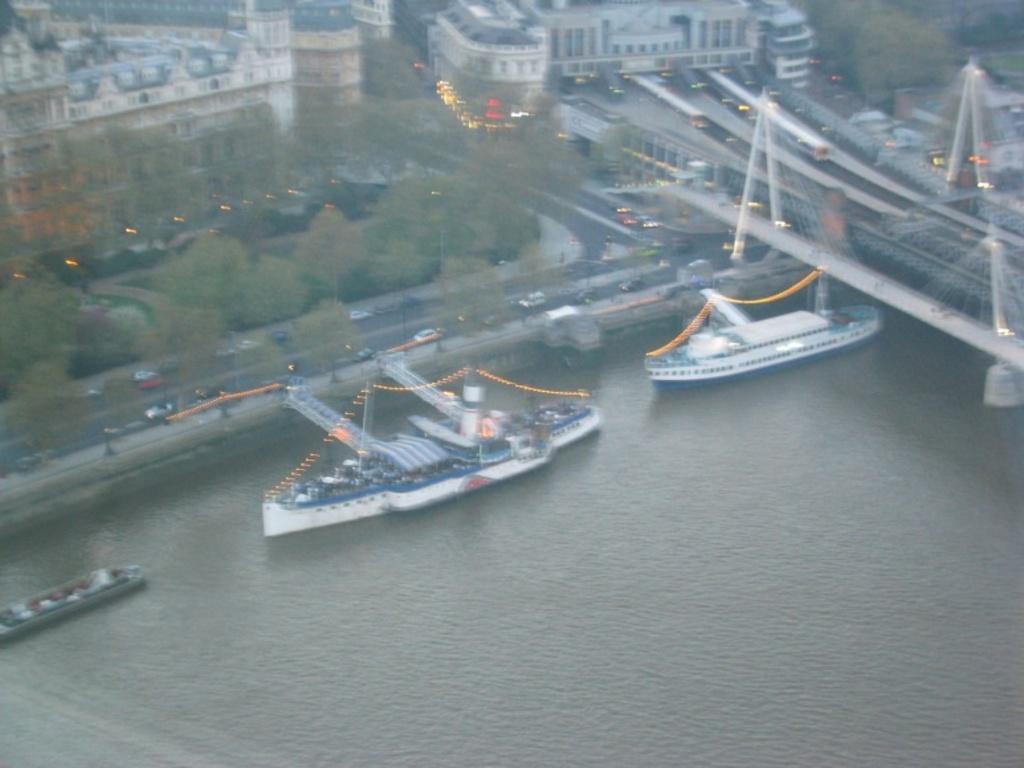Could you give a brief overview of what you see in this image? This is an aerial view of image which is slightly blurred, where I can see ships floating on the water, I can see vehicles are moving on road, I can see bridges, trees and buildings. 